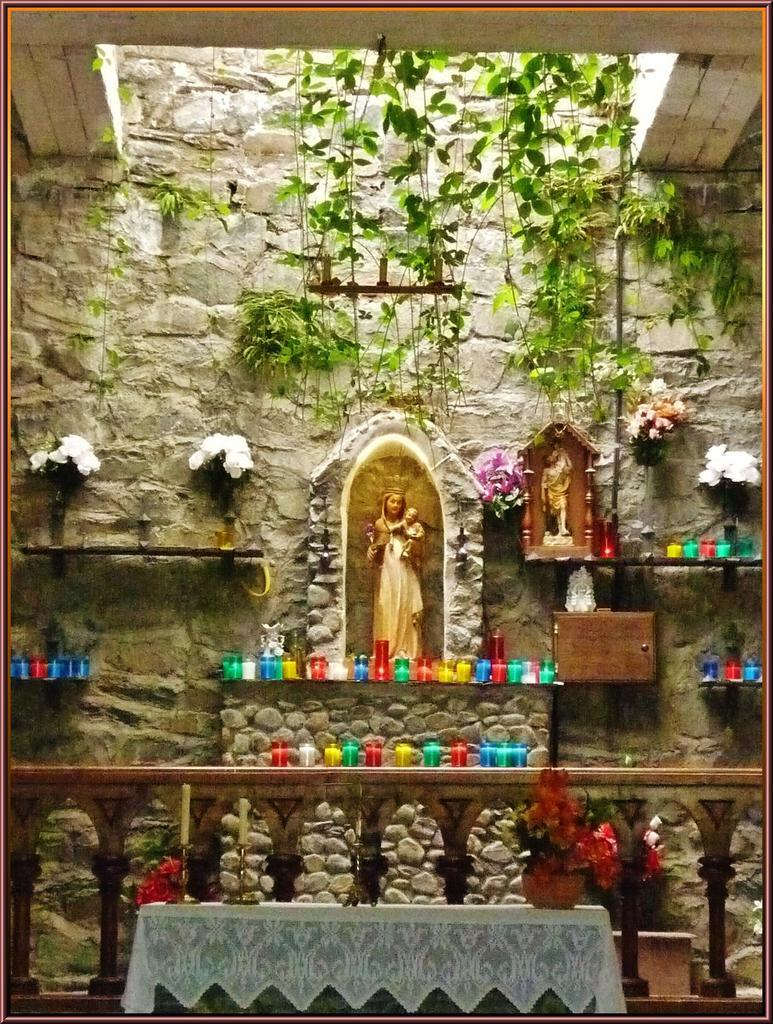What type of objects can be seen in the image? There are statues, colorful candles, flower pots, and objects on racks in the image. Can you describe the decorative elements in the image? The colorful candles and flower pots add a decorative touch to the scene. What is visible in the background of the image? There is a brick wall and plants in the background of the image. What type of party is being held in the image? There is no party depicted in the image; it features statues, colorful candles, flower pots, and objects on racks. What is the value of the airport in the image? There is no airport present in the image, so it is not possible to determine its value. 